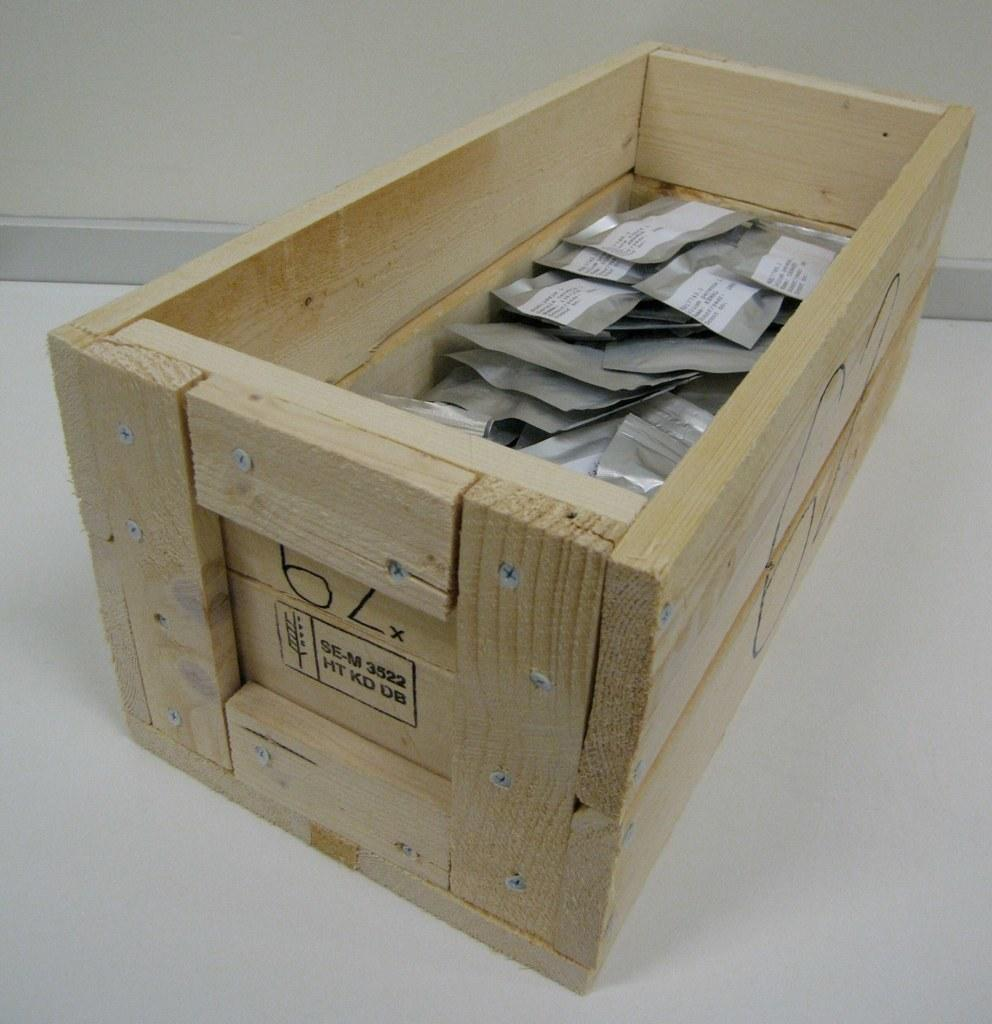Provide a one-sentence caption for the provided image. A wooden crate with the number 62 written on it. 